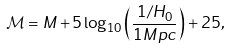Convert formula to latex. <formula><loc_0><loc_0><loc_500><loc_500>\mathcal { M } = M + 5 \log _ { 1 0 } \left ( \frac { 1 / H _ { 0 } } { 1 M p c } \right ) + 2 5 ,</formula> 